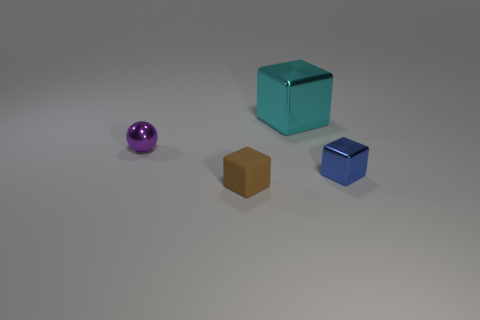Subtract 1 cubes. How many cubes are left? 2 Add 2 small purple metallic cylinders. How many objects exist? 6 Subtract all cubes. How many objects are left? 1 Subtract all purple metallic balls. Subtract all large red matte cylinders. How many objects are left? 3 Add 3 small matte objects. How many small matte objects are left? 4 Add 2 small purple shiny blocks. How many small purple shiny blocks exist? 2 Subtract 0 yellow spheres. How many objects are left? 4 